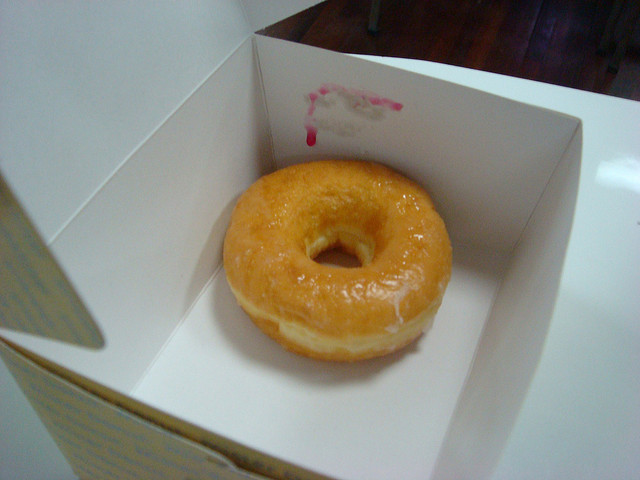How many donuts  is there? 1 